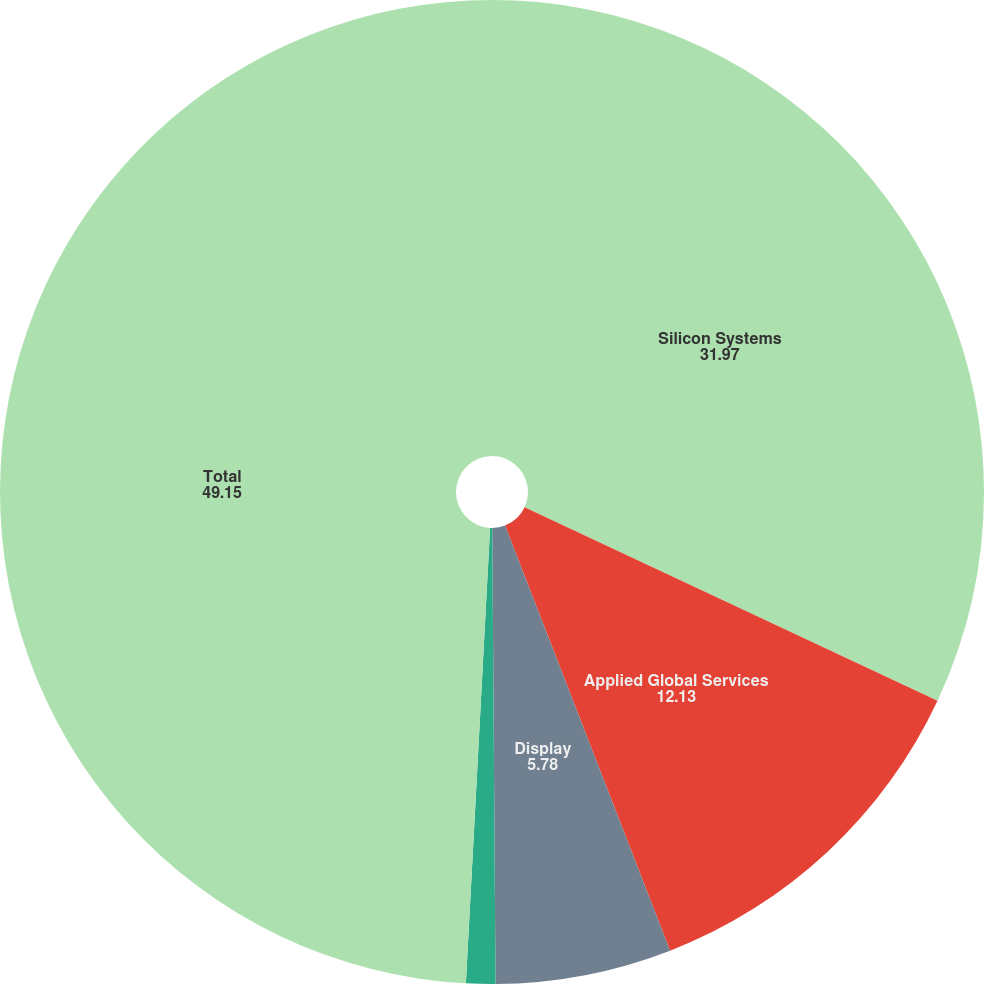Convert chart to OTSL. <chart><loc_0><loc_0><loc_500><loc_500><pie_chart><fcel>Silicon Systems<fcel>Applied Global Services<fcel>Display<fcel>Energy and Environmental<fcel>Total<nl><fcel>31.97%<fcel>12.13%<fcel>5.78%<fcel>0.96%<fcel>49.15%<nl></chart> 